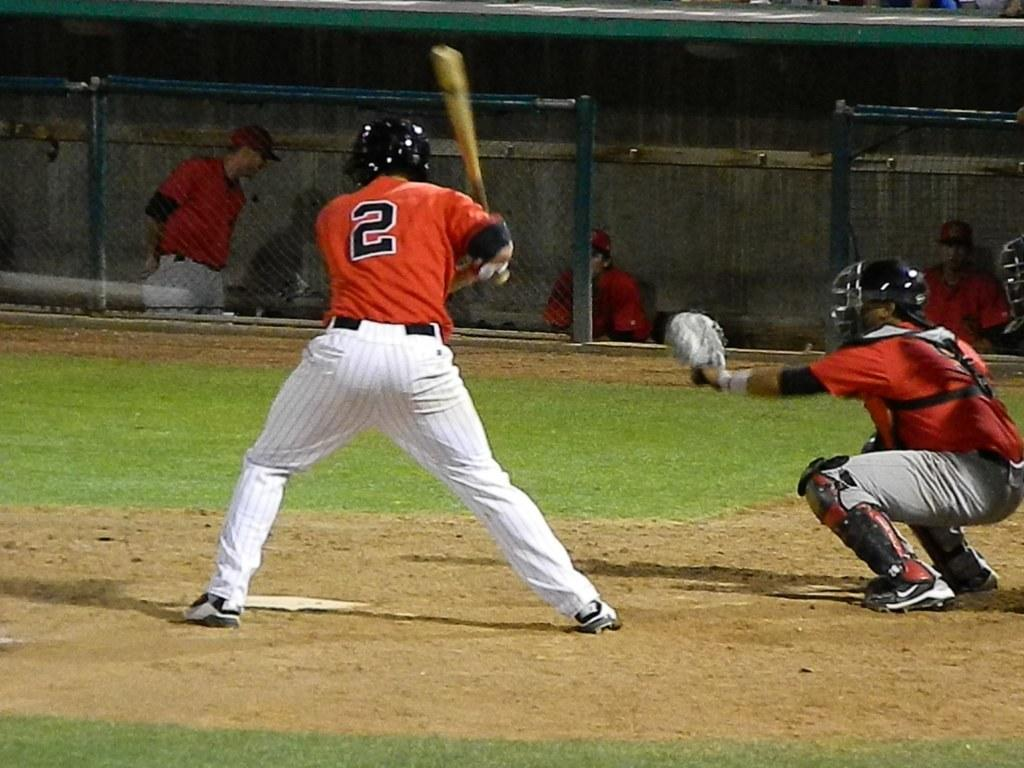<image>
Summarize the visual content of the image. Two baseball players in red jerseys - one has the number 2 on it in black and white lettering 